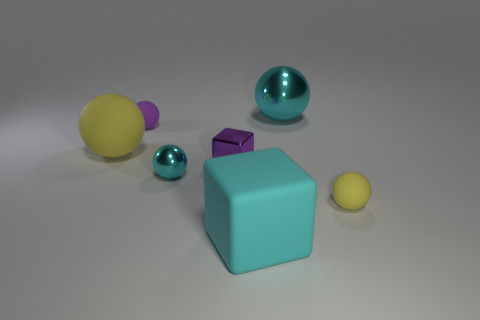Subtract all yellow matte spheres. How many spheres are left? 3 Subtract all purple cubes. How many cubes are left? 1 Add 1 big metal cylinders. How many objects exist? 8 Subtract all balls. How many objects are left? 2 Subtract all blue balls. How many yellow blocks are left? 0 Add 1 tiny blue metallic objects. How many tiny blue metallic objects exist? 1 Subtract 1 cyan cubes. How many objects are left? 6 Subtract 1 blocks. How many blocks are left? 1 Subtract all yellow spheres. Subtract all purple cylinders. How many spheres are left? 3 Subtract all tiny balls. Subtract all small red balls. How many objects are left? 4 